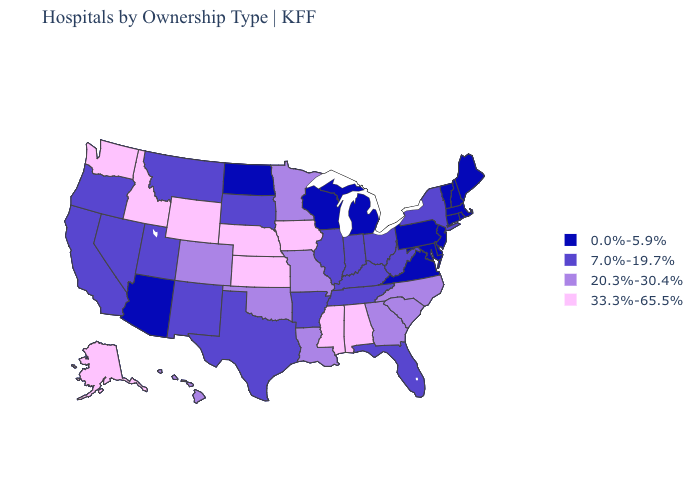Among the states that border Pennsylvania , does Delaware have the highest value?
Short answer required. No. What is the value of Wyoming?
Be succinct. 33.3%-65.5%. What is the lowest value in the West?
Be succinct. 0.0%-5.9%. Does California have the highest value in the West?
Short answer required. No. Does New Hampshire have a lower value than Maine?
Be succinct. No. Is the legend a continuous bar?
Answer briefly. No. Does the first symbol in the legend represent the smallest category?
Keep it brief. Yes. Which states have the lowest value in the West?
Give a very brief answer. Arizona. How many symbols are there in the legend?
Keep it brief. 4. Among the states that border Colorado , does Utah have the highest value?
Quick response, please. No. Which states have the lowest value in the USA?
Give a very brief answer. Arizona, Connecticut, Delaware, Maine, Maryland, Massachusetts, Michigan, New Hampshire, New Jersey, North Dakota, Pennsylvania, Rhode Island, Vermont, Virginia, Wisconsin. Does Massachusetts have the highest value in the Northeast?
Give a very brief answer. No. What is the value of Nebraska?
Write a very short answer. 33.3%-65.5%. Name the states that have a value in the range 20.3%-30.4%?
Give a very brief answer. Colorado, Georgia, Hawaii, Louisiana, Minnesota, Missouri, North Carolina, Oklahoma, South Carolina. What is the value of Arizona?
Concise answer only. 0.0%-5.9%. 